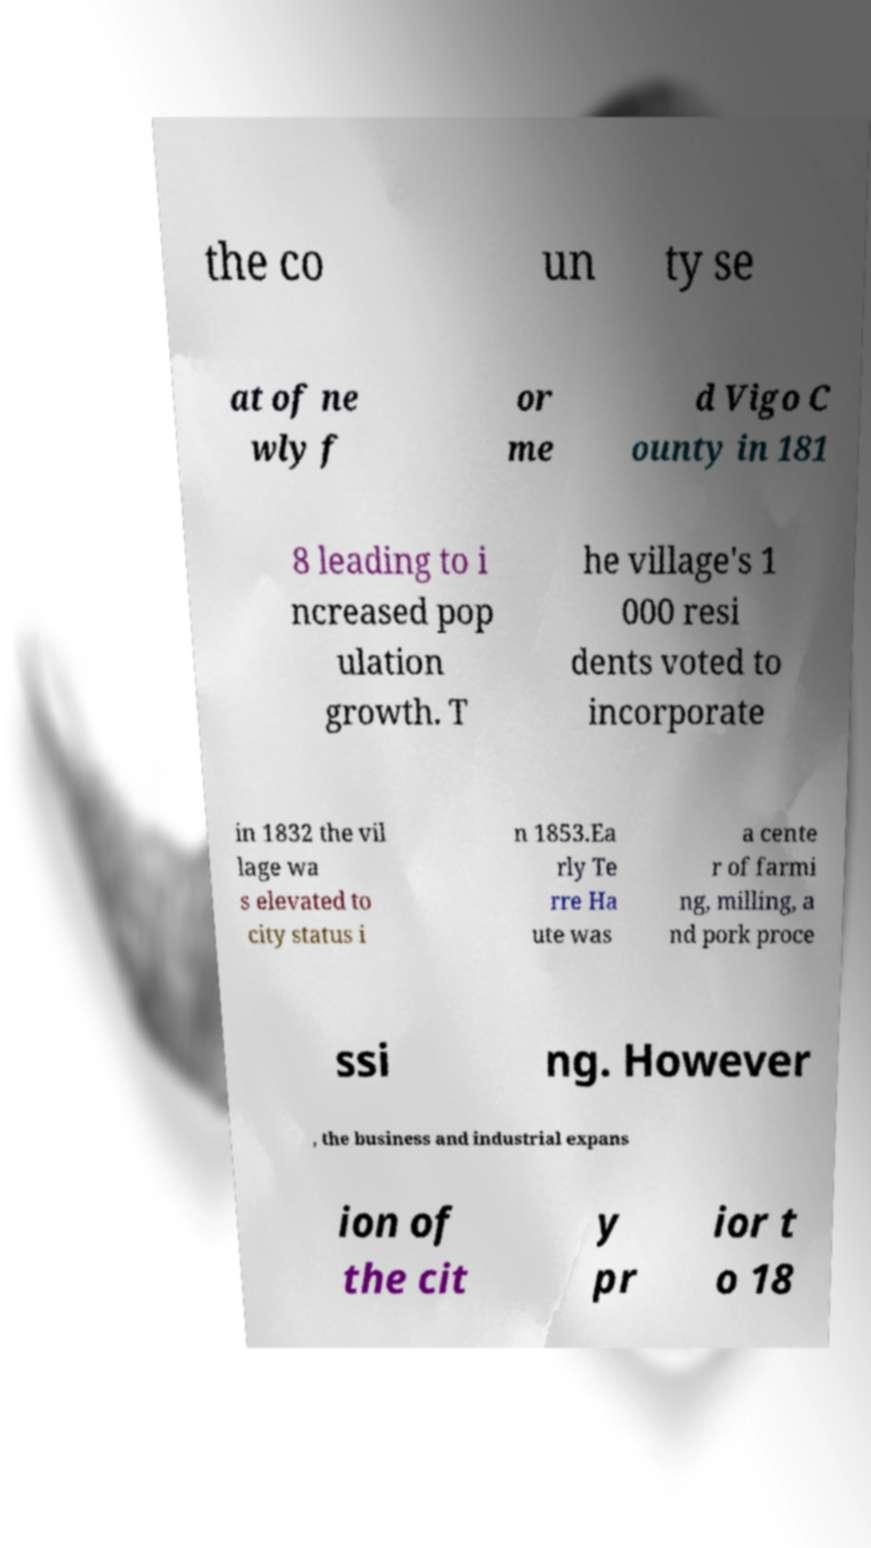Can you read and provide the text displayed in the image?This photo seems to have some interesting text. Can you extract and type it out for me? the co un ty se at of ne wly f or me d Vigo C ounty in 181 8 leading to i ncreased pop ulation growth. T he village's 1 000 resi dents voted to incorporate in 1832 the vil lage wa s elevated to city status i n 1853.Ea rly Te rre Ha ute was a cente r of farmi ng, milling, a nd pork proce ssi ng. However , the business and industrial expans ion of the cit y pr ior t o 18 